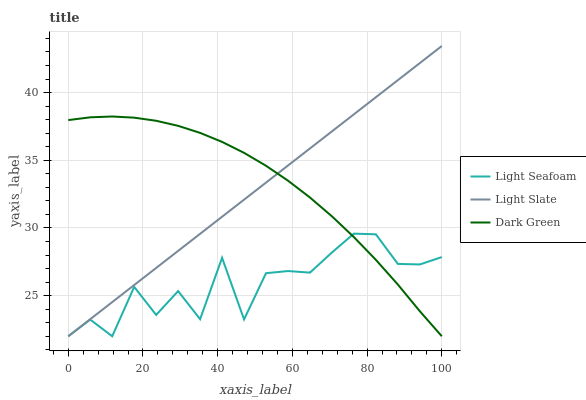Does Light Seafoam have the minimum area under the curve?
Answer yes or no. Yes. Does Dark Green have the maximum area under the curve?
Answer yes or no. Yes. Does Dark Green have the minimum area under the curve?
Answer yes or no. No. Does Light Seafoam have the maximum area under the curve?
Answer yes or no. No. Is Light Slate the smoothest?
Answer yes or no. Yes. Is Light Seafoam the roughest?
Answer yes or no. Yes. Is Dark Green the smoothest?
Answer yes or no. No. Is Dark Green the roughest?
Answer yes or no. No. Does Light Slate have the highest value?
Answer yes or no. Yes. Does Dark Green have the highest value?
Answer yes or no. No. Does Dark Green intersect Light Seafoam?
Answer yes or no. Yes. Is Dark Green less than Light Seafoam?
Answer yes or no. No. Is Dark Green greater than Light Seafoam?
Answer yes or no. No. 